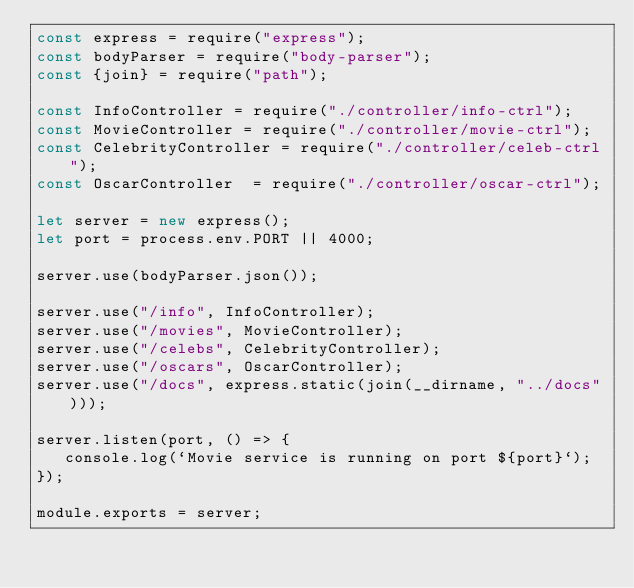Convert code to text. <code><loc_0><loc_0><loc_500><loc_500><_JavaScript_>const express = require("express");
const bodyParser = require("body-parser");
const {join} = require("path");

const InfoController = require("./controller/info-ctrl");
const MovieController = require("./controller/movie-ctrl");
const CelebrityController = require("./controller/celeb-ctrl");
const OscarController  = require("./controller/oscar-ctrl");

let server = new express();
let port = process.env.PORT || 4000;

server.use(bodyParser.json());

server.use("/info", InfoController);
server.use("/movies", MovieController);
server.use("/celebs", CelebrityController);
server.use("/oscars", OscarController);
server.use("/docs", express.static(join(__dirname, "../docs")));

server.listen(port, () => {
   console.log(`Movie service is running on port ${port}`);
});

module.exports = server;</code> 